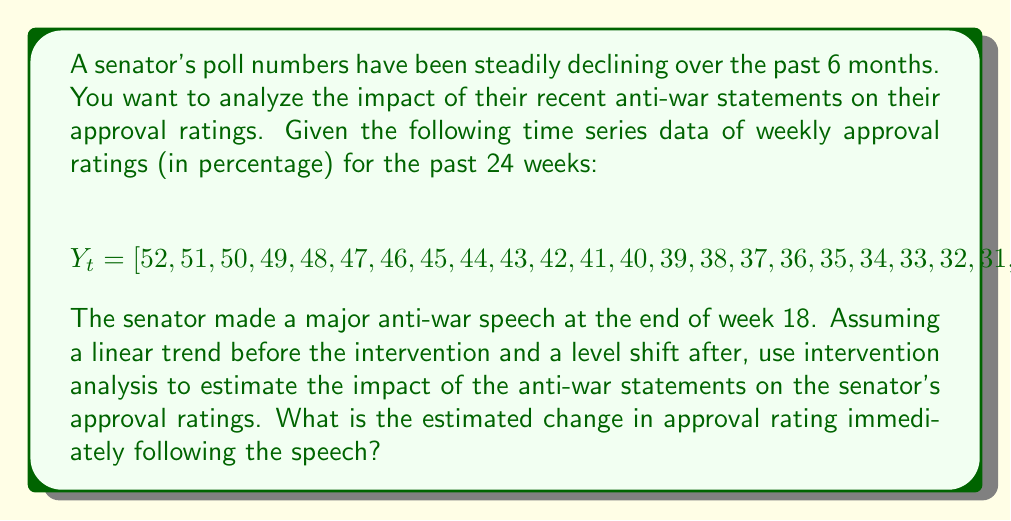Show me your answer to this math problem. To solve this problem, we'll use intervention analysis with a step function. We'll model the time series as:

$$Y_t = \beta_0 + \beta_1t + \omega I_t + \epsilon_t$$

Where:
- $\beta_0$ is the intercept
- $\beta_1$ is the slope of the linear trend
- $\omega$ is the impact of the intervention
- $I_t$ is an indicator variable (0 before intervention, 1 after)
- $\epsilon_t$ is the error term

Step 1: Estimate the linear trend before the intervention (weeks 1-18)
Using linear regression on the first 18 data points:

$$\hat{Y_t} = 53.5 - 1t$$

Step 2: Calculate the expected values for weeks 19-24 without intervention
Using the equation from Step 1:

$$\hat{Y}_{19} = 53.5 - 1(19) = 34.5$$
$$\hat{Y}_{20} = 53.5 - 1(20) = 33.5$$
$$\hat{Y}_{21} = 53.5 - 1(21) = 32.5$$
$$\hat{Y}_{22} = 53.5 - 1(22) = 31.5$$
$$\hat{Y}_{23} = 53.5 - 1(23) = 30.5$$
$$\hat{Y}_{24} = 53.5 - 1(24) = 29.5$$

Step 3: Calculate the differences between observed and expected values
$$\text{Differences} = [34 - 34.5, 33 - 33.5, 32 - 32.5, 31 - 31.5, 30 - 30.5, 29 - 29.5]$$
$$= [-0.5, -0.5, -0.5, -0.5, -0.5, -0.5]$$

Step 4: Calculate the average difference
$$\text{Average Difference} = \frac{-0.5 - 0.5 - 0.5 - 0.5 - 0.5 - 0.5}{6} = -0.5$$

The average difference of -0.5 represents the estimated change in approval rating immediately following the anti-war speech.
Answer: The estimated change in approval rating immediately following the anti-war speech is -0.5 percentage points. 